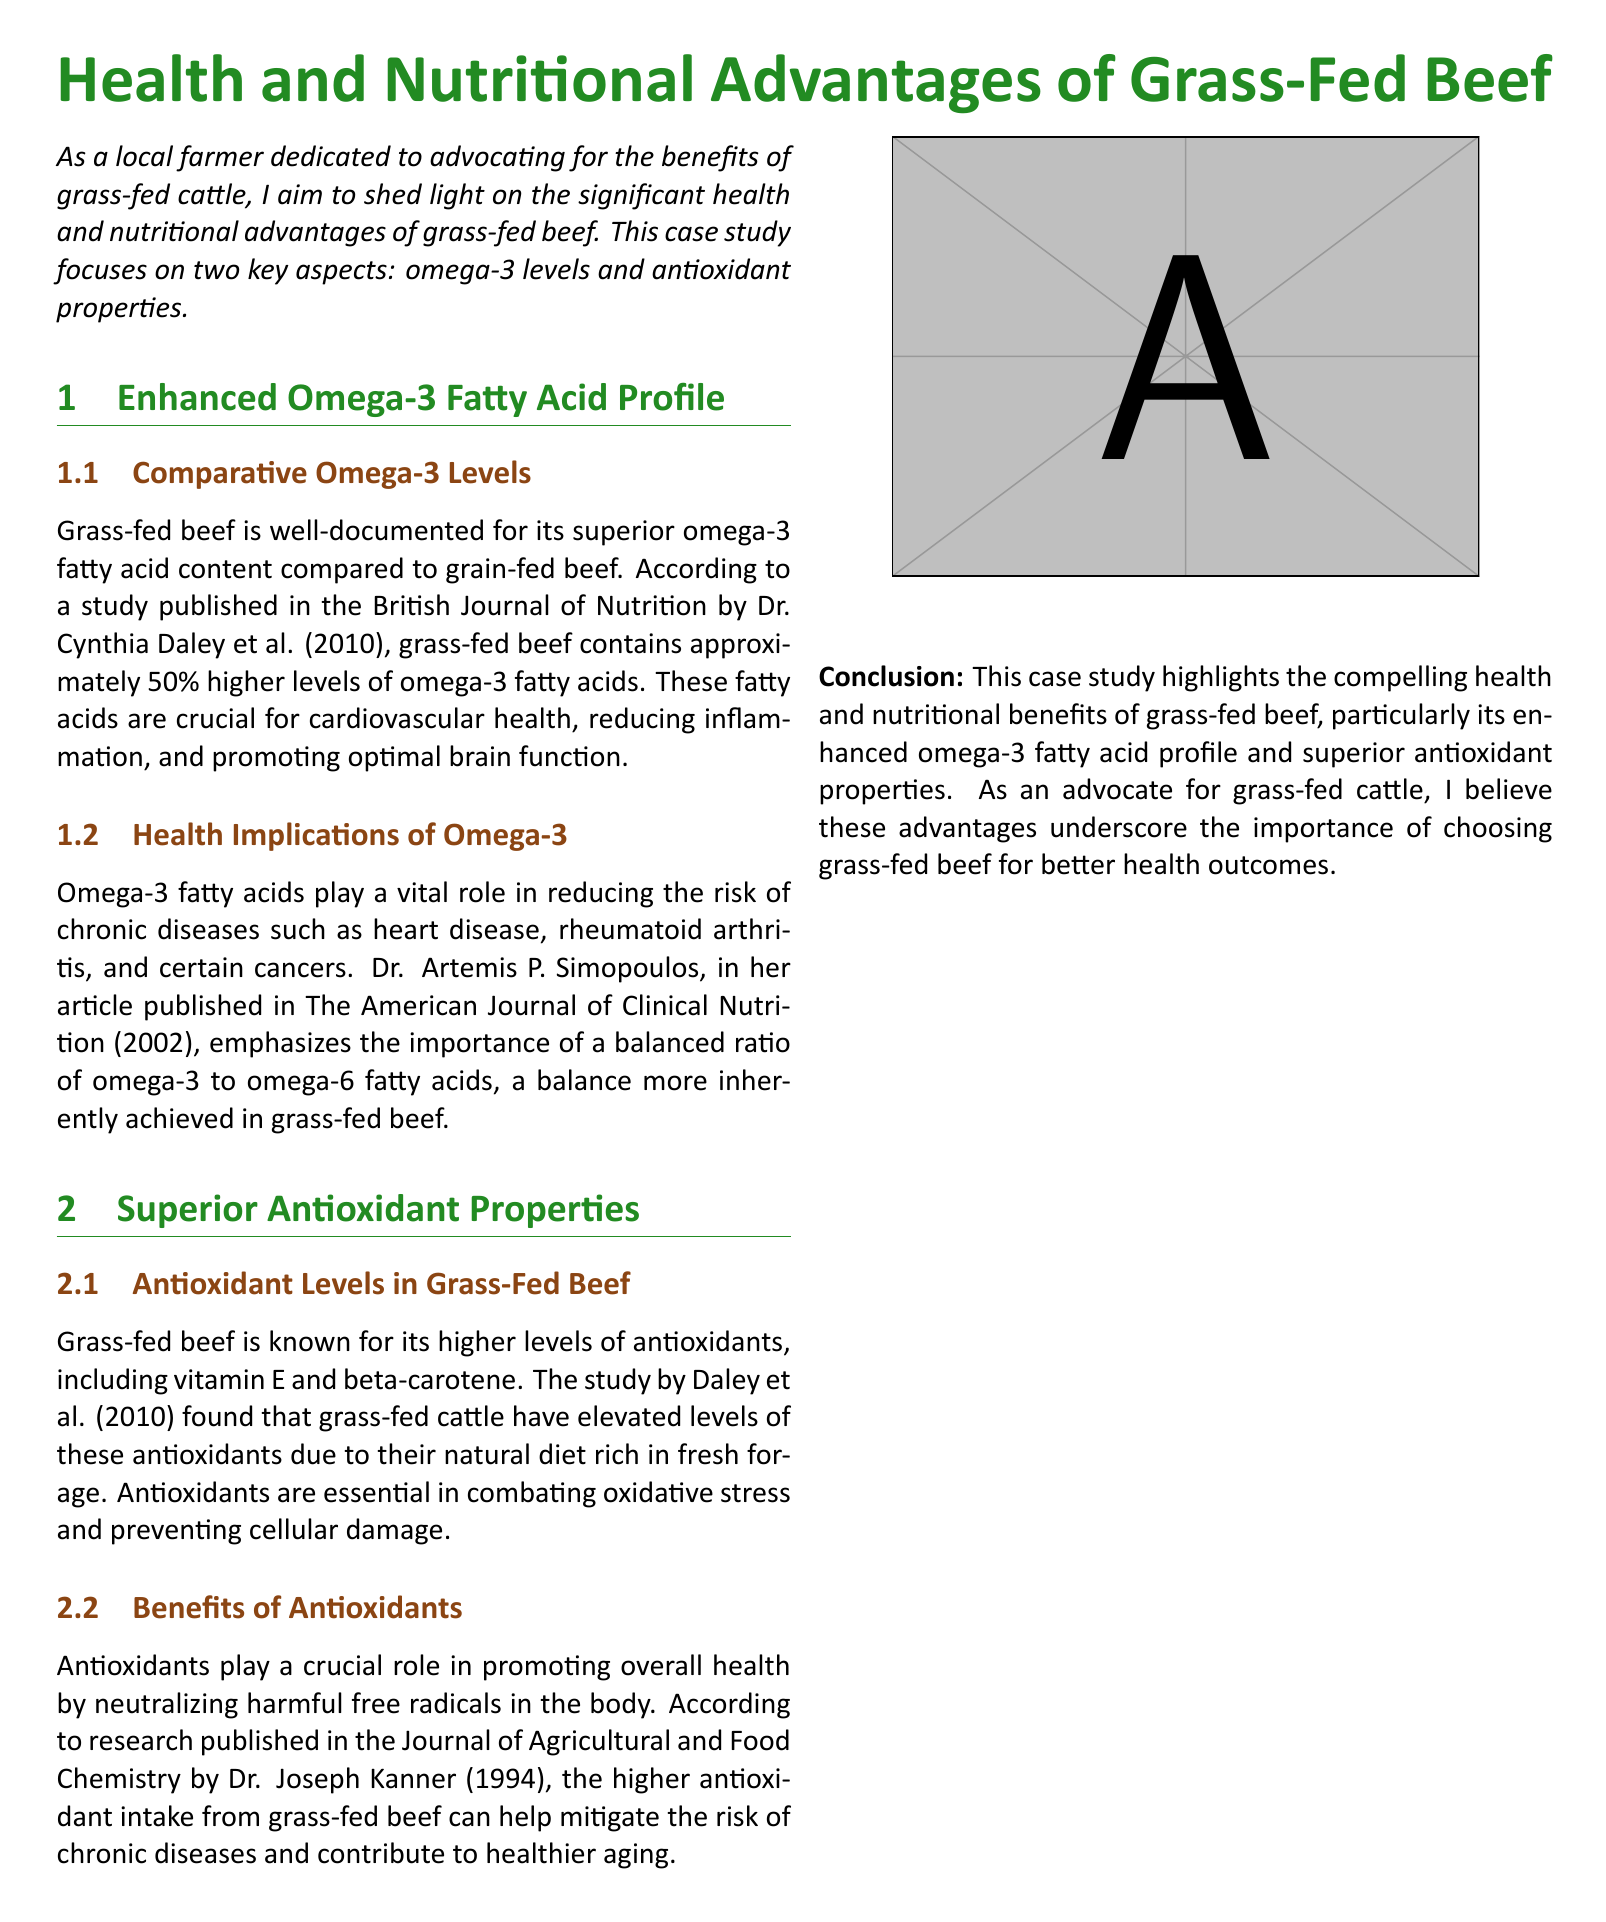What is the primary focus of this case study? The case study focuses on the health and nutritional advantages of grass-fed beef, particularly omega-3 levels and antioxidant properties.
Answer: health and nutritional advantages of grass-fed beef Who conducted the study on comparative omega-3 levels mentioned in the document? The study on omega-3 levels was conducted by Dr. Cynthia Daley et al.
Answer: Dr. Cynthia Daley et al How much higher are omega-3 fatty acids in grass-fed beef compared to grain-fed beef? The document states that grass-fed beef contains approximately 50% higher levels of omega-3 fatty acids compared to grain-fed beef.
Answer: 50% What are two antioxidants found in higher levels in grass-fed beef? The document mentions that vitamin E and beta-carotene are two antioxidants found in higher levels in grass-fed beef.
Answer: vitamin E and beta-carotene According to Dr. Artemis P. Simopoulos, what is important for reducing the risk of chronic diseases? Dr. Simopoulos emphasizes the importance of a balanced ratio of omega-3 to omega-6 fatty acids.
Answer: balanced ratio of omega-3 to omega-6 fatty acids What health benefits do antioxidants provide according to the document? Antioxidants play a crucial role in promoting overall health by neutralizing harmful free radicals in the body.
Answer: neutralizing harmful free radicals Which journal published research by Dr. Joseph Kanner on antioxidants? The research by Dr. Joseph Kanner on antioxidants was published in the Journal of Agricultural and Food Chemistry.
Answer: Journal of Agricultural and Food Chemistry What are the two key aspects examined in this case study? The key aspects examined in this case study are omega-3 levels and antioxidant properties of grass-fed beef.
Answer: omega-3 levels and antioxidant properties 